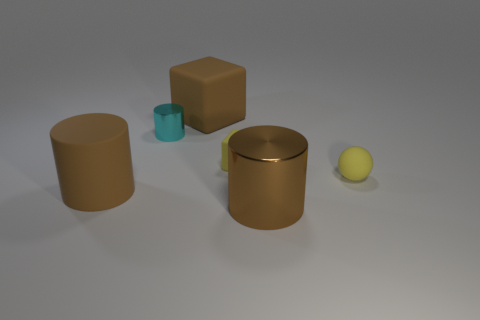How big is the object that is both left of the tiny matte cube and in front of the small metallic cylinder?
Your answer should be compact. Large. What is the shape of the metal thing that is the same color as the rubber cylinder?
Your answer should be compact. Cylinder. What color is the big matte cylinder?
Ensure brevity in your answer.  Brown. There is a metal cylinder that is behind the large rubber cylinder; how big is it?
Make the answer very short. Small. There is a brown thing in front of the brown thing on the left side of the tiny cyan metal cylinder; what number of yellow matte things are to the right of it?
Give a very brief answer. 1. The cylinder that is to the right of the big matte block that is right of the big matte cylinder is what color?
Provide a short and direct response. Brown. Is there a yellow cube of the same size as the rubber sphere?
Offer a very short reply. Yes. What is the material of the large brown cylinder behind the big object that is on the right side of the brown rubber thing on the right side of the small cyan object?
Your answer should be very brief. Rubber. What number of rubber things are on the right side of the big thing that is behind the tiny rubber ball?
Keep it short and to the point. 2. There is a shiny thing in front of the cyan metal cylinder; is it the same size as the tiny yellow matte cube?
Make the answer very short. No. 